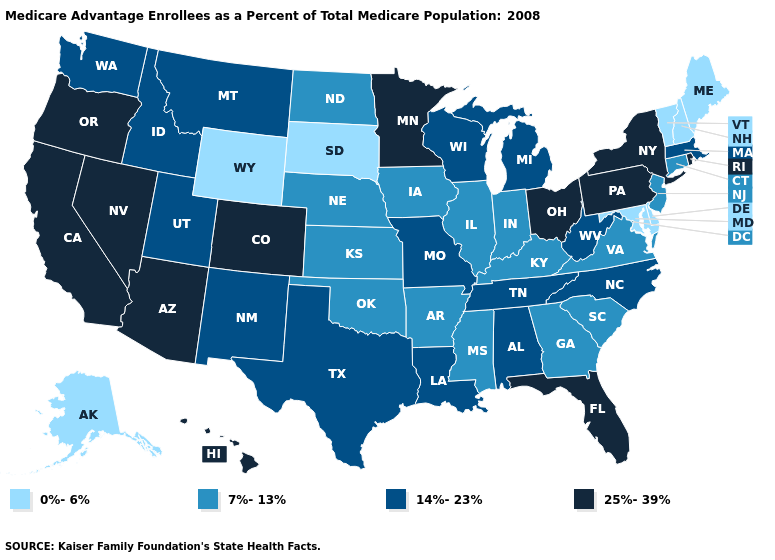How many symbols are there in the legend?
Write a very short answer. 4. Does the first symbol in the legend represent the smallest category?
Concise answer only. Yes. Among the states that border Montana , does Idaho have the highest value?
Concise answer only. Yes. Does the first symbol in the legend represent the smallest category?
Give a very brief answer. Yes. Among the states that border Georgia , does South Carolina have the lowest value?
Write a very short answer. Yes. What is the lowest value in the USA?
Quick response, please. 0%-6%. What is the lowest value in the USA?
Quick response, please. 0%-6%. What is the value of Texas?
Answer briefly. 14%-23%. What is the highest value in the West ?
Keep it brief. 25%-39%. Name the states that have a value in the range 14%-23%?
Keep it brief. Alabama, Idaho, Louisiana, Massachusetts, Michigan, Missouri, Montana, North Carolina, New Mexico, Tennessee, Texas, Utah, Washington, Wisconsin, West Virginia. What is the value of Iowa?
Be succinct. 7%-13%. Name the states that have a value in the range 25%-39%?
Concise answer only. Arizona, California, Colorado, Florida, Hawaii, Minnesota, Nevada, New York, Ohio, Oregon, Pennsylvania, Rhode Island. Name the states that have a value in the range 7%-13%?
Short answer required. Arkansas, Connecticut, Georgia, Iowa, Illinois, Indiana, Kansas, Kentucky, Mississippi, North Dakota, Nebraska, New Jersey, Oklahoma, South Carolina, Virginia. Which states have the lowest value in the MidWest?
Give a very brief answer. South Dakota. Which states have the lowest value in the MidWest?
Keep it brief. South Dakota. 